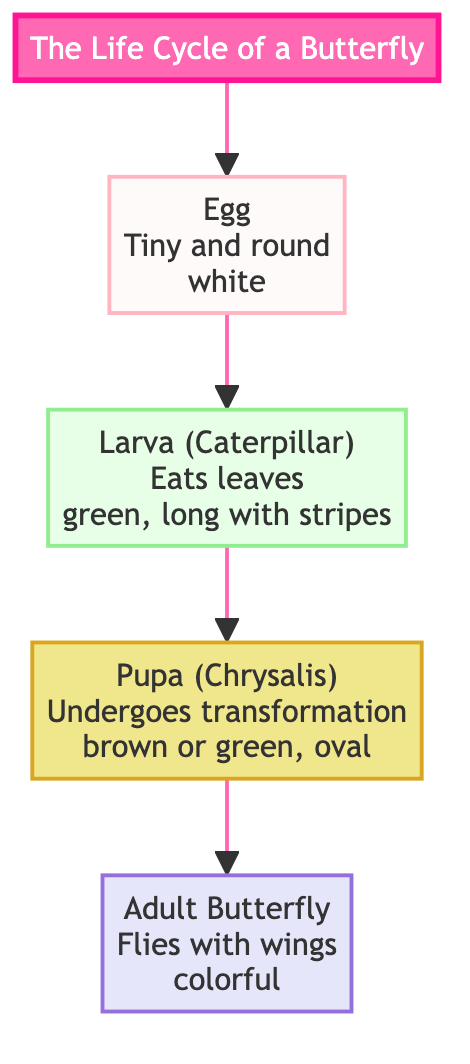What is the first stage in the life cycle of a butterfly? The diagram shows that the life cycle begins with an "Egg" which is the first node in the flow.
Answer: Egg How does the larva (caterpillar) look according to the diagram? The diagram explicitly describes the larva as "green, long with stripes," which details its appearance.
Answer: green, long with stripes What is the color of the pupa (chrysalis)? The diagram states that the pupa can be "brown or green," providing two color options for this stage.
Answer: brown or green How many stages are there in the life cycle of a butterfly? The flowchart outlines four distinct stages: Egg, Larva, Pupa, and Adult, counting them gives a total of four stages.
Answer: 4 What does the adult butterfly do? According to the diagram, the adult butterfly is described as being able to "Fly with wings," specifying its main activity.
Answer: Fly with wings What follows the larva in the life cycle? The diagram clearly shows that after the Larva stage, the next stage is the Pupa stage, indicating the flow of development.
Answer: Pupa What type of creature is represented in the adult stage? The adult stage is represented by an "Adult Butterfly," which defines the creature that emerges in this stage.
Answer: Adult Butterfly What is unique about the egg stage? The diagram notes that the egg is "Tiny and round," highlighting its distinctive features at this stage.
Answer: Tiny and round 